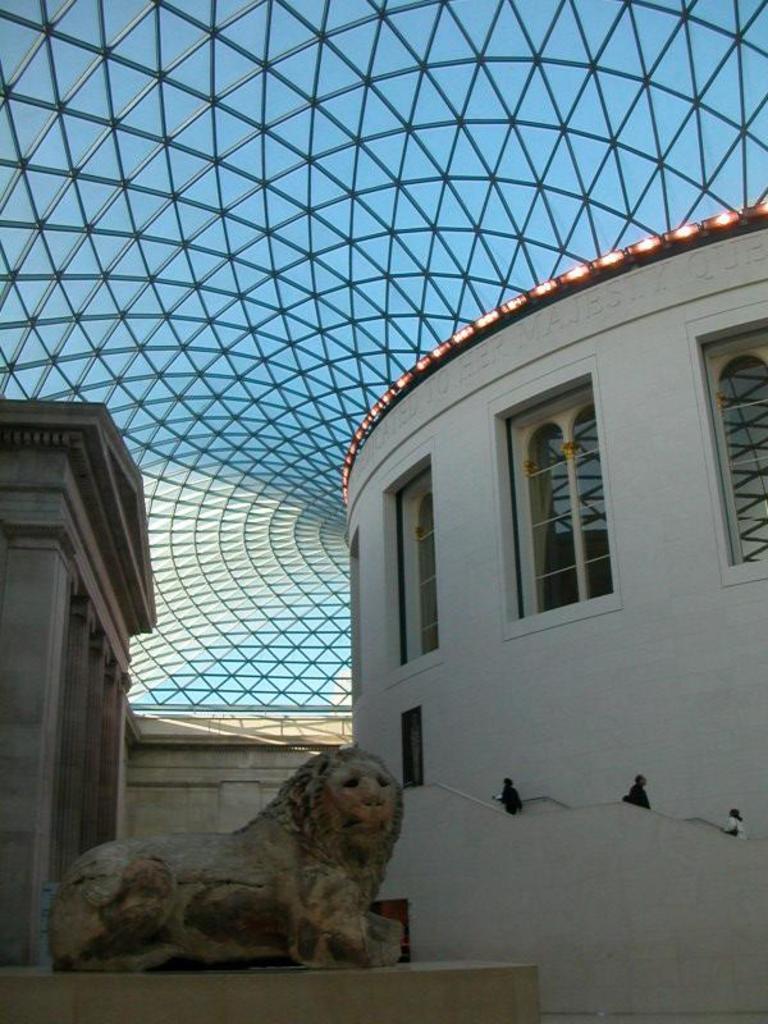Can you describe this image briefly? In the image we can see in front there is a lion statue and behind there is a building and people are standing on the building. On the top there is a glass roof. 